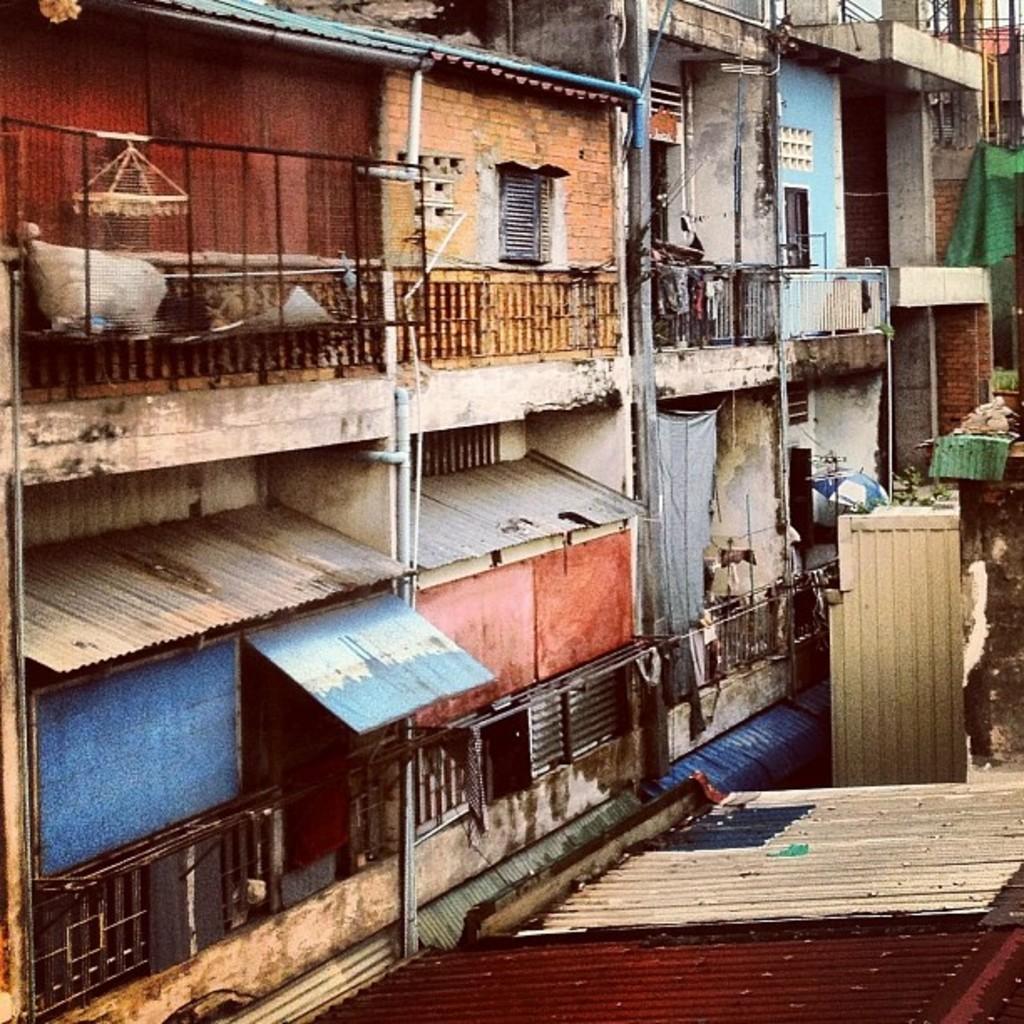Could you give a brief overview of what you see in this image? In this image we can see some buildings and there are some pipes, iron sheets, fencing, windows to the buildings. 